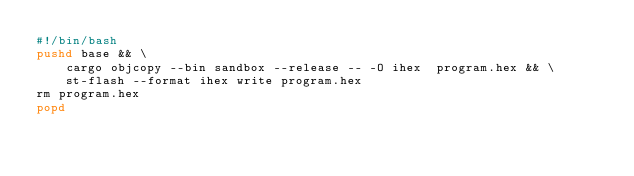Convert code to text. <code><loc_0><loc_0><loc_500><loc_500><_Bash_>#!/bin/bash
pushd base && \
    cargo objcopy --bin sandbox --release -- -O ihex  program.hex && \
    st-flash --format ihex write program.hex
rm program.hex
popd


</code> 